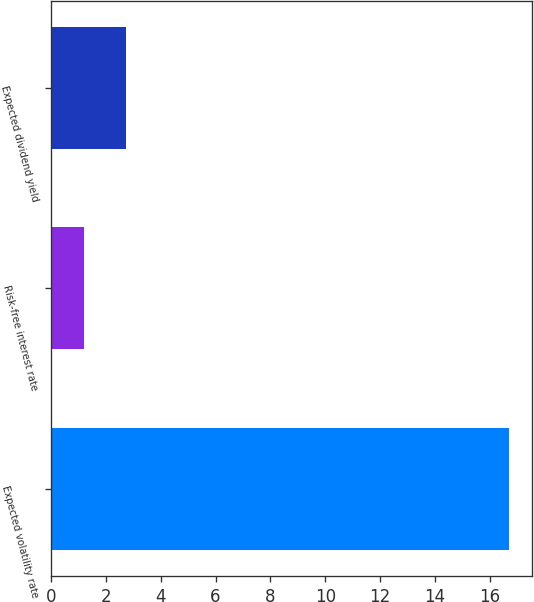<chart> <loc_0><loc_0><loc_500><loc_500><bar_chart><fcel>Expected volatility rate<fcel>Risk-free interest rate<fcel>Expected dividend yield<nl><fcel>16.7<fcel>1.2<fcel>2.75<nl></chart> 